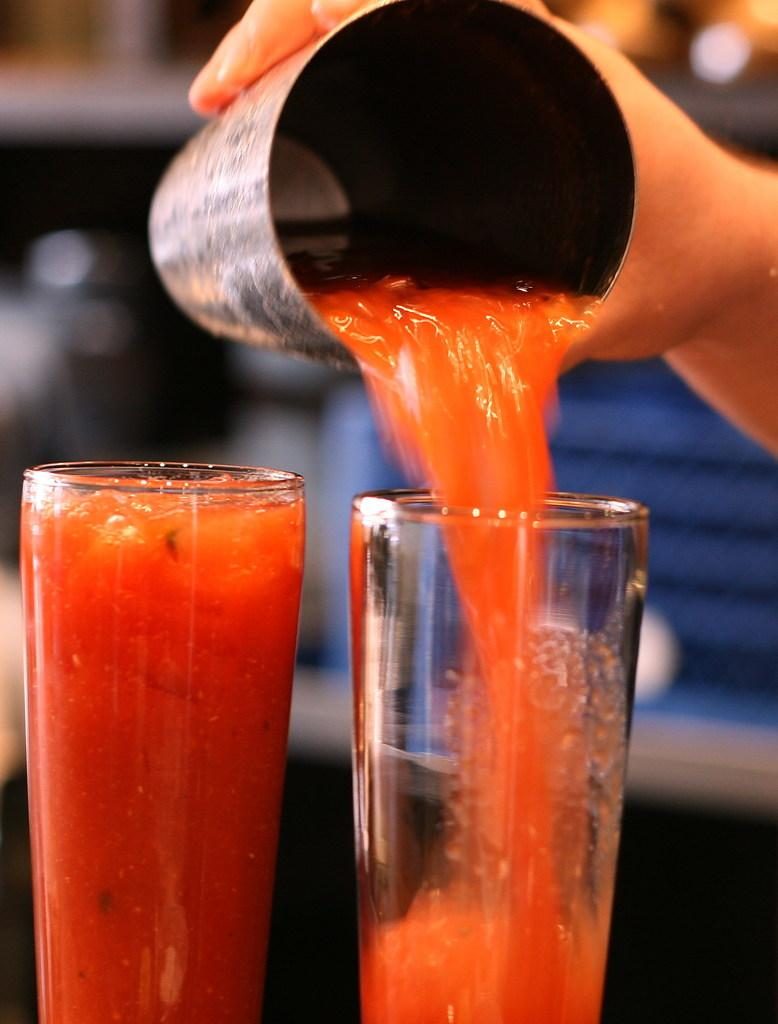How many glasses of drinks can be seen in the image? There are 2 glasses of drinks in the image. What is the person in the image doing with the drinks? The person is holding a steel glass of drink and pouring it into the right side glass. What material is the glass that the person is holding? The glass that the person is holding is made of steel. Can you describe the background of the image? The background of the image is blurred. What type of animals can be seen at the zoo in the image? There is no zoo or animals present in the image; it features glasses of drinks and a person pouring a drink. 